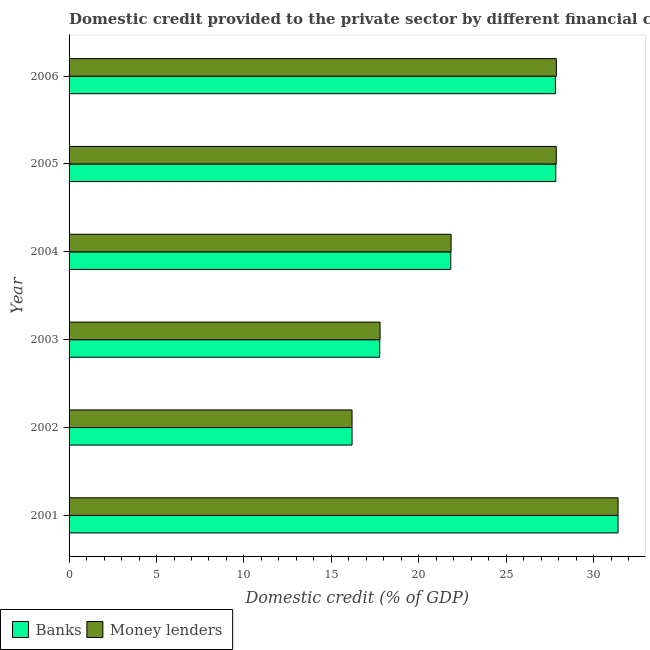How many groups of bars are there?
Your answer should be compact. 6. Are the number of bars per tick equal to the number of legend labels?
Your answer should be very brief. Yes. How many bars are there on the 3rd tick from the top?
Make the answer very short. 2. What is the domestic credit provided by banks in 2003?
Your answer should be compact. 17.76. Across all years, what is the maximum domestic credit provided by banks?
Make the answer very short. 31.39. Across all years, what is the minimum domestic credit provided by banks?
Provide a succinct answer. 16.18. What is the total domestic credit provided by banks in the graph?
Give a very brief answer. 142.79. What is the difference between the domestic credit provided by money lenders in 2004 and that in 2005?
Your answer should be very brief. -6.01. What is the difference between the domestic credit provided by money lenders in 2004 and the domestic credit provided by banks in 2006?
Offer a very short reply. -5.97. What is the average domestic credit provided by money lenders per year?
Keep it short and to the point. 23.82. In the year 2001, what is the difference between the domestic credit provided by money lenders and domestic credit provided by banks?
Provide a succinct answer. 0. In how many years, is the domestic credit provided by money lenders greater than 10 %?
Keep it short and to the point. 6. What is the ratio of the domestic credit provided by money lenders in 2005 to that in 2006?
Offer a very short reply. 1. Is the domestic credit provided by money lenders in 2004 less than that in 2006?
Your response must be concise. Yes. What is the difference between the highest and the second highest domestic credit provided by money lenders?
Make the answer very short. 3.52. What is the difference between the highest and the lowest domestic credit provided by money lenders?
Provide a succinct answer. 15.21. Is the sum of the domestic credit provided by banks in 2001 and 2004 greater than the maximum domestic credit provided by money lenders across all years?
Provide a short and direct response. Yes. What does the 2nd bar from the top in 2004 represents?
Make the answer very short. Banks. What does the 1st bar from the bottom in 2004 represents?
Provide a succinct answer. Banks. How many bars are there?
Provide a short and direct response. 12. Are all the bars in the graph horizontal?
Your response must be concise. Yes. What is the difference between two consecutive major ticks on the X-axis?
Your response must be concise. 5. Does the graph contain any zero values?
Provide a succinct answer. No. Where does the legend appear in the graph?
Provide a succinct answer. Bottom left. How are the legend labels stacked?
Your answer should be very brief. Horizontal. What is the title of the graph?
Provide a succinct answer. Domestic credit provided to the private sector by different financial corporations in Serbia. What is the label or title of the X-axis?
Make the answer very short. Domestic credit (% of GDP). What is the label or title of the Y-axis?
Provide a short and direct response. Year. What is the Domestic credit (% of GDP) of Banks in 2001?
Offer a very short reply. 31.39. What is the Domestic credit (% of GDP) in Money lenders in 2001?
Ensure brevity in your answer.  31.39. What is the Domestic credit (% of GDP) in Banks in 2002?
Provide a succinct answer. 16.18. What is the Domestic credit (% of GDP) in Money lenders in 2002?
Offer a very short reply. 16.18. What is the Domestic credit (% of GDP) in Banks in 2003?
Provide a succinct answer. 17.76. What is the Domestic credit (% of GDP) in Money lenders in 2003?
Offer a very short reply. 17.78. What is the Domestic credit (% of GDP) in Banks in 2004?
Provide a succinct answer. 21.82. What is the Domestic credit (% of GDP) of Money lenders in 2004?
Your answer should be compact. 21.84. What is the Domestic credit (% of GDP) of Banks in 2005?
Provide a succinct answer. 27.83. What is the Domestic credit (% of GDP) in Money lenders in 2005?
Provide a short and direct response. 27.86. What is the Domestic credit (% of GDP) of Banks in 2006?
Your response must be concise. 27.81. What is the Domestic credit (% of GDP) in Money lenders in 2006?
Provide a short and direct response. 27.86. Across all years, what is the maximum Domestic credit (% of GDP) of Banks?
Offer a terse response. 31.39. Across all years, what is the maximum Domestic credit (% of GDP) in Money lenders?
Provide a short and direct response. 31.39. Across all years, what is the minimum Domestic credit (% of GDP) of Banks?
Your answer should be compact. 16.18. Across all years, what is the minimum Domestic credit (% of GDP) of Money lenders?
Ensure brevity in your answer.  16.18. What is the total Domestic credit (% of GDP) in Banks in the graph?
Provide a short and direct response. 142.79. What is the total Domestic credit (% of GDP) of Money lenders in the graph?
Provide a succinct answer. 142.91. What is the difference between the Domestic credit (% of GDP) of Banks in 2001 and that in 2002?
Give a very brief answer. 15.21. What is the difference between the Domestic credit (% of GDP) of Money lenders in 2001 and that in 2002?
Make the answer very short. 15.21. What is the difference between the Domestic credit (% of GDP) of Banks in 2001 and that in 2003?
Your answer should be compact. 13.63. What is the difference between the Domestic credit (% of GDP) of Money lenders in 2001 and that in 2003?
Give a very brief answer. 13.61. What is the difference between the Domestic credit (% of GDP) in Banks in 2001 and that in 2004?
Provide a succinct answer. 9.56. What is the difference between the Domestic credit (% of GDP) of Money lenders in 2001 and that in 2004?
Ensure brevity in your answer.  9.55. What is the difference between the Domestic credit (% of GDP) of Banks in 2001 and that in 2005?
Your response must be concise. 3.56. What is the difference between the Domestic credit (% of GDP) in Money lenders in 2001 and that in 2005?
Offer a very short reply. 3.53. What is the difference between the Domestic credit (% of GDP) in Banks in 2001 and that in 2006?
Your response must be concise. 3.58. What is the difference between the Domestic credit (% of GDP) in Money lenders in 2001 and that in 2006?
Make the answer very short. 3.52. What is the difference between the Domestic credit (% of GDP) of Banks in 2002 and that in 2003?
Give a very brief answer. -1.58. What is the difference between the Domestic credit (% of GDP) of Money lenders in 2002 and that in 2003?
Ensure brevity in your answer.  -1.6. What is the difference between the Domestic credit (% of GDP) in Banks in 2002 and that in 2004?
Keep it short and to the point. -5.64. What is the difference between the Domestic credit (% of GDP) of Money lenders in 2002 and that in 2004?
Make the answer very short. -5.66. What is the difference between the Domestic credit (% of GDP) in Banks in 2002 and that in 2005?
Offer a terse response. -11.65. What is the difference between the Domestic credit (% of GDP) in Money lenders in 2002 and that in 2005?
Make the answer very short. -11.68. What is the difference between the Domestic credit (% of GDP) of Banks in 2002 and that in 2006?
Your response must be concise. -11.63. What is the difference between the Domestic credit (% of GDP) of Money lenders in 2002 and that in 2006?
Keep it short and to the point. -11.68. What is the difference between the Domestic credit (% of GDP) of Banks in 2003 and that in 2004?
Provide a short and direct response. -4.06. What is the difference between the Domestic credit (% of GDP) of Money lenders in 2003 and that in 2004?
Offer a very short reply. -4.06. What is the difference between the Domestic credit (% of GDP) in Banks in 2003 and that in 2005?
Provide a succinct answer. -10.07. What is the difference between the Domestic credit (% of GDP) in Money lenders in 2003 and that in 2005?
Offer a terse response. -10.08. What is the difference between the Domestic credit (% of GDP) in Banks in 2003 and that in 2006?
Make the answer very short. -10.05. What is the difference between the Domestic credit (% of GDP) in Money lenders in 2003 and that in 2006?
Keep it short and to the point. -10.08. What is the difference between the Domestic credit (% of GDP) of Banks in 2004 and that in 2005?
Your answer should be very brief. -6. What is the difference between the Domestic credit (% of GDP) of Money lenders in 2004 and that in 2005?
Ensure brevity in your answer.  -6.01. What is the difference between the Domestic credit (% of GDP) in Banks in 2004 and that in 2006?
Your answer should be very brief. -5.98. What is the difference between the Domestic credit (% of GDP) of Money lenders in 2004 and that in 2006?
Give a very brief answer. -6.02. What is the difference between the Domestic credit (% of GDP) in Banks in 2005 and that in 2006?
Give a very brief answer. 0.02. What is the difference between the Domestic credit (% of GDP) in Money lenders in 2005 and that in 2006?
Your answer should be very brief. -0.01. What is the difference between the Domestic credit (% of GDP) of Banks in 2001 and the Domestic credit (% of GDP) of Money lenders in 2002?
Provide a short and direct response. 15.21. What is the difference between the Domestic credit (% of GDP) in Banks in 2001 and the Domestic credit (% of GDP) in Money lenders in 2003?
Keep it short and to the point. 13.61. What is the difference between the Domestic credit (% of GDP) of Banks in 2001 and the Domestic credit (% of GDP) of Money lenders in 2004?
Your answer should be compact. 9.55. What is the difference between the Domestic credit (% of GDP) of Banks in 2001 and the Domestic credit (% of GDP) of Money lenders in 2005?
Give a very brief answer. 3.53. What is the difference between the Domestic credit (% of GDP) of Banks in 2001 and the Domestic credit (% of GDP) of Money lenders in 2006?
Provide a succinct answer. 3.52. What is the difference between the Domestic credit (% of GDP) of Banks in 2002 and the Domestic credit (% of GDP) of Money lenders in 2003?
Keep it short and to the point. -1.6. What is the difference between the Domestic credit (% of GDP) of Banks in 2002 and the Domestic credit (% of GDP) of Money lenders in 2004?
Provide a succinct answer. -5.66. What is the difference between the Domestic credit (% of GDP) of Banks in 2002 and the Domestic credit (% of GDP) of Money lenders in 2005?
Provide a short and direct response. -11.68. What is the difference between the Domestic credit (% of GDP) of Banks in 2002 and the Domestic credit (% of GDP) of Money lenders in 2006?
Offer a very short reply. -11.68. What is the difference between the Domestic credit (% of GDP) in Banks in 2003 and the Domestic credit (% of GDP) in Money lenders in 2004?
Provide a short and direct response. -4.08. What is the difference between the Domestic credit (% of GDP) in Banks in 2003 and the Domestic credit (% of GDP) in Money lenders in 2005?
Offer a very short reply. -10.09. What is the difference between the Domestic credit (% of GDP) in Banks in 2003 and the Domestic credit (% of GDP) in Money lenders in 2006?
Provide a succinct answer. -10.1. What is the difference between the Domestic credit (% of GDP) of Banks in 2004 and the Domestic credit (% of GDP) of Money lenders in 2005?
Provide a succinct answer. -6.03. What is the difference between the Domestic credit (% of GDP) of Banks in 2004 and the Domestic credit (% of GDP) of Money lenders in 2006?
Your response must be concise. -6.04. What is the difference between the Domestic credit (% of GDP) in Banks in 2005 and the Domestic credit (% of GDP) in Money lenders in 2006?
Give a very brief answer. -0.03. What is the average Domestic credit (% of GDP) in Banks per year?
Give a very brief answer. 23.8. What is the average Domestic credit (% of GDP) of Money lenders per year?
Offer a very short reply. 23.82. In the year 2003, what is the difference between the Domestic credit (% of GDP) in Banks and Domestic credit (% of GDP) in Money lenders?
Make the answer very short. -0.02. In the year 2004, what is the difference between the Domestic credit (% of GDP) of Banks and Domestic credit (% of GDP) of Money lenders?
Your response must be concise. -0.02. In the year 2005, what is the difference between the Domestic credit (% of GDP) in Banks and Domestic credit (% of GDP) in Money lenders?
Ensure brevity in your answer.  -0.03. In the year 2006, what is the difference between the Domestic credit (% of GDP) of Banks and Domestic credit (% of GDP) of Money lenders?
Your answer should be compact. -0.05. What is the ratio of the Domestic credit (% of GDP) in Banks in 2001 to that in 2002?
Offer a very short reply. 1.94. What is the ratio of the Domestic credit (% of GDP) in Money lenders in 2001 to that in 2002?
Provide a short and direct response. 1.94. What is the ratio of the Domestic credit (% of GDP) in Banks in 2001 to that in 2003?
Make the answer very short. 1.77. What is the ratio of the Domestic credit (% of GDP) of Money lenders in 2001 to that in 2003?
Your response must be concise. 1.77. What is the ratio of the Domestic credit (% of GDP) of Banks in 2001 to that in 2004?
Provide a short and direct response. 1.44. What is the ratio of the Domestic credit (% of GDP) of Money lenders in 2001 to that in 2004?
Offer a very short reply. 1.44. What is the ratio of the Domestic credit (% of GDP) in Banks in 2001 to that in 2005?
Your response must be concise. 1.13. What is the ratio of the Domestic credit (% of GDP) of Money lenders in 2001 to that in 2005?
Keep it short and to the point. 1.13. What is the ratio of the Domestic credit (% of GDP) of Banks in 2001 to that in 2006?
Your answer should be compact. 1.13. What is the ratio of the Domestic credit (% of GDP) in Money lenders in 2001 to that in 2006?
Offer a very short reply. 1.13. What is the ratio of the Domestic credit (% of GDP) in Banks in 2002 to that in 2003?
Make the answer very short. 0.91. What is the ratio of the Domestic credit (% of GDP) of Money lenders in 2002 to that in 2003?
Your response must be concise. 0.91. What is the ratio of the Domestic credit (% of GDP) of Banks in 2002 to that in 2004?
Your answer should be very brief. 0.74. What is the ratio of the Domestic credit (% of GDP) of Money lenders in 2002 to that in 2004?
Offer a terse response. 0.74. What is the ratio of the Domestic credit (% of GDP) of Banks in 2002 to that in 2005?
Provide a succinct answer. 0.58. What is the ratio of the Domestic credit (% of GDP) of Money lenders in 2002 to that in 2005?
Ensure brevity in your answer.  0.58. What is the ratio of the Domestic credit (% of GDP) in Banks in 2002 to that in 2006?
Keep it short and to the point. 0.58. What is the ratio of the Domestic credit (% of GDP) of Money lenders in 2002 to that in 2006?
Offer a terse response. 0.58. What is the ratio of the Domestic credit (% of GDP) in Banks in 2003 to that in 2004?
Provide a succinct answer. 0.81. What is the ratio of the Domestic credit (% of GDP) of Money lenders in 2003 to that in 2004?
Provide a short and direct response. 0.81. What is the ratio of the Domestic credit (% of GDP) in Banks in 2003 to that in 2005?
Your response must be concise. 0.64. What is the ratio of the Domestic credit (% of GDP) of Money lenders in 2003 to that in 2005?
Provide a short and direct response. 0.64. What is the ratio of the Domestic credit (% of GDP) of Banks in 2003 to that in 2006?
Offer a terse response. 0.64. What is the ratio of the Domestic credit (% of GDP) in Money lenders in 2003 to that in 2006?
Your answer should be very brief. 0.64. What is the ratio of the Domestic credit (% of GDP) in Banks in 2004 to that in 2005?
Keep it short and to the point. 0.78. What is the ratio of the Domestic credit (% of GDP) in Money lenders in 2004 to that in 2005?
Give a very brief answer. 0.78. What is the ratio of the Domestic credit (% of GDP) of Banks in 2004 to that in 2006?
Your response must be concise. 0.78. What is the ratio of the Domestic credit (% of GDP) in Money lenders in 2004 to that in 2006?
Your answer should be compact. 0.78. What is the ratio of the Domestic credit (% of GDP) in Money lenders in 2005 to that in 2006?
Your response must be concise. 1. What is the difference between the highest and the second highest Domestic credit (% of GDP) of Banks?
Your response must be concise. 3.56. What is the difference between the highest and the second highest Domestic credit (% of GDP) of Money lenders?
Offer a terse response. 3.52. What is the difference between the highest and the lowest Domestic credit (% of GDP) of Banks?
Your response must be concise. 15.21. What is the difference between the highest and the lowest Domestic credit (% of GDP) of Money lenders?
Your answer should be compact. 15.21. 